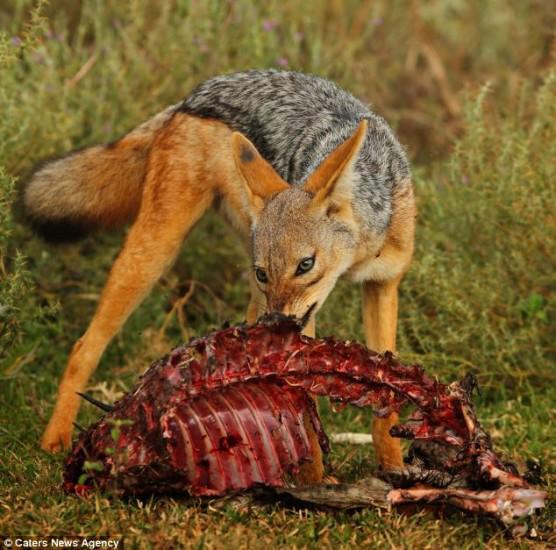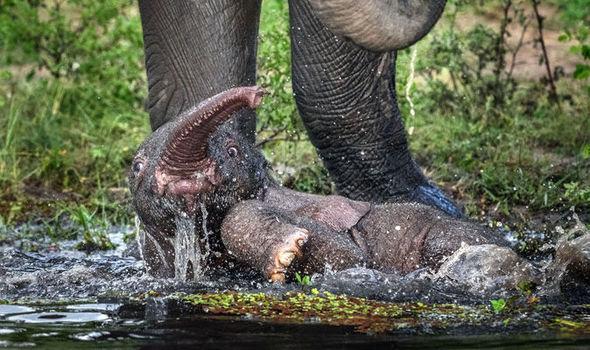The first image is the image on the left, the second image is the image on the right. Assess this claim about the two images: "There is at least one hyena in the left image.". Correct or not? Answer yes or no. No. The first image is the image on the left, the second image is the image on the right. Evaluate the accuracy of this statement regarding the images: "The right image contains exactly one hyena.". Is it true? Answer yes or no. No. 